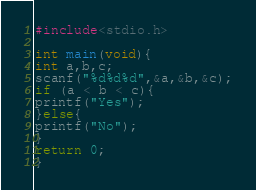<code> <loc_0><loc_0><loc_500><loc_500><_C_>#include<stdio.h>

int main(void){
int a,b,c;
scanf("%d%d%d",&a,&b,&c);
if (a < b < c){
printf("Yes");
}else{
printf("No");
}
return 0;
}</code> 